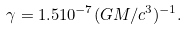Convert formula to latex. <formula><loc_0><loc_0><loc_500><loc_500>\gamma = 1 . 5 1 0 ^ { - 7 } ( G M / c ^ { 3 } ) ^ { - 1 } .</formula> 